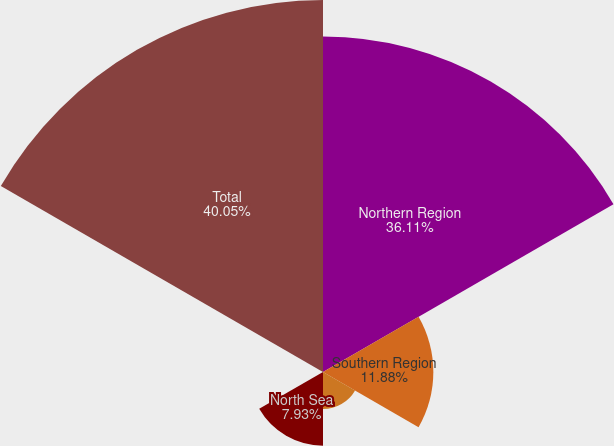Convert chart. <chart><loc_0><loc_0><loc_500><loc_500><pie_chart><fcel>Northern Region<fcel>Southern Region<fcel>West Africa<fcel>North Sea<fcel>China<fcel>Total<nl><fcel>36.11%<fcel>11.88%<fcel>3.99%<fcel>7.93%<fcel>0.04%<fcel>40.05%<nl></chart> 